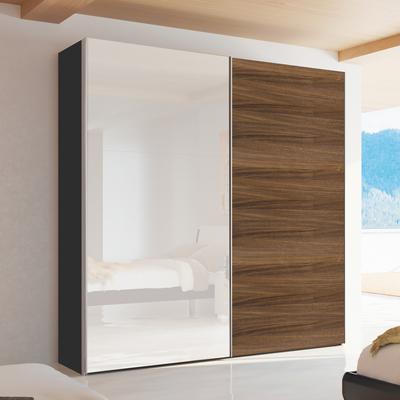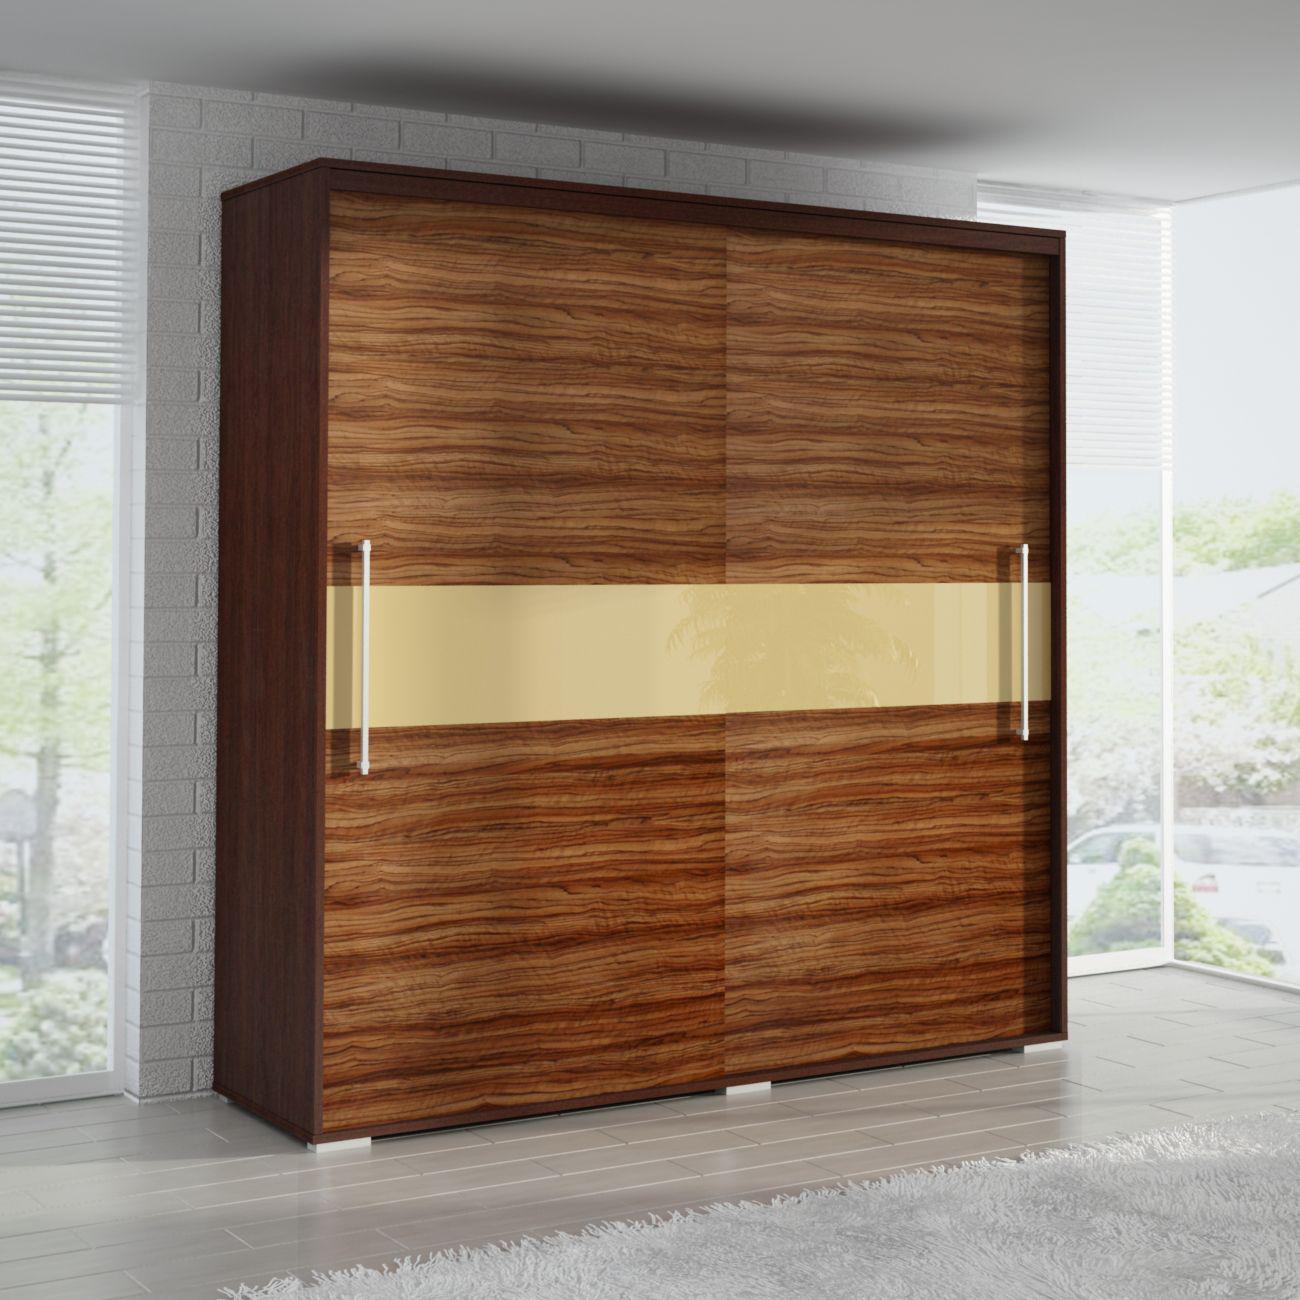The first image is the image on the left, the second image is the image on the right. For the images displayed, is the sentence "There are four black panels on the wooden closet in the image on the right." factually correct? Answer yes or no. No. The first image is the image on the left, the second image is the image on the right. Given the left and right images, does the statement "Two wardrobes are each divided vertically down the middle to accommodate equal size solid doors." hold true? Answer yes or no. Yes. 